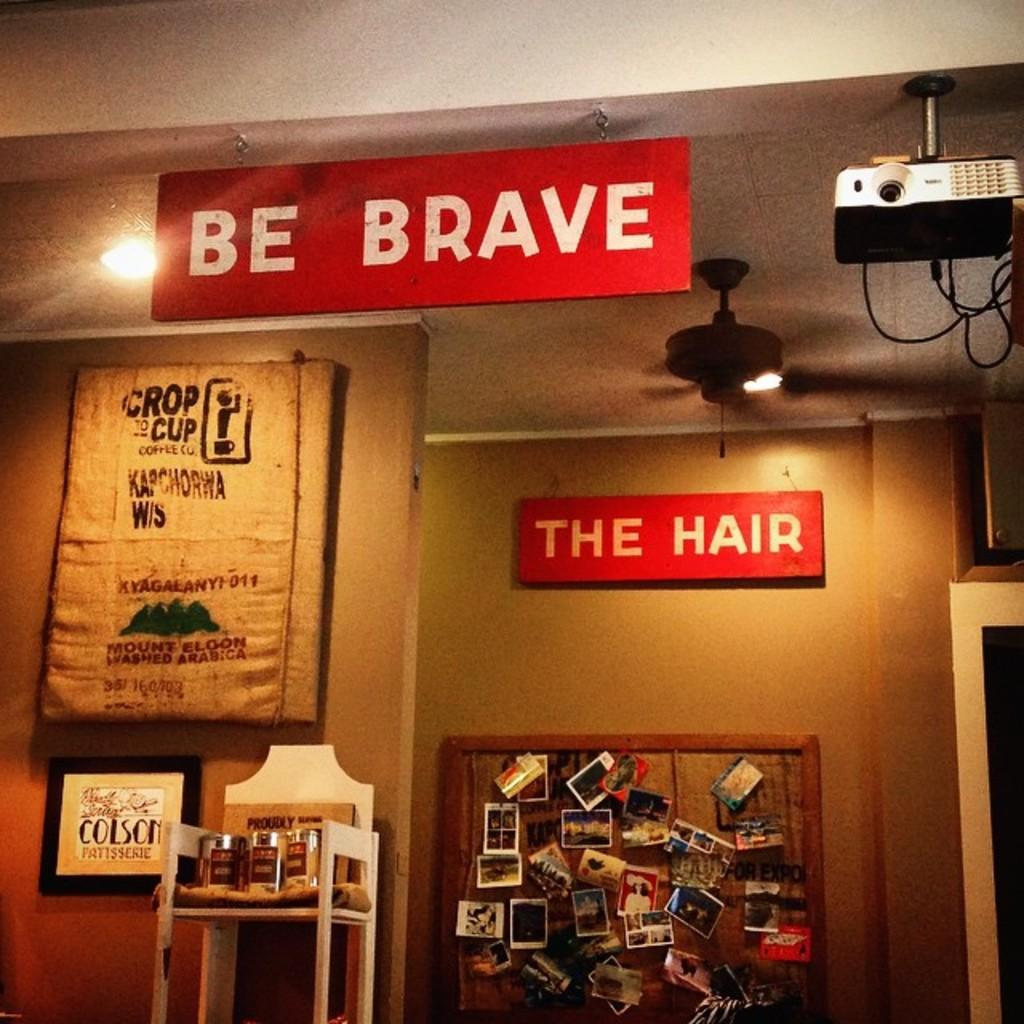<image>
Offer a succinct explanation of the picture presented. Two red signs say be brave and the hair. 